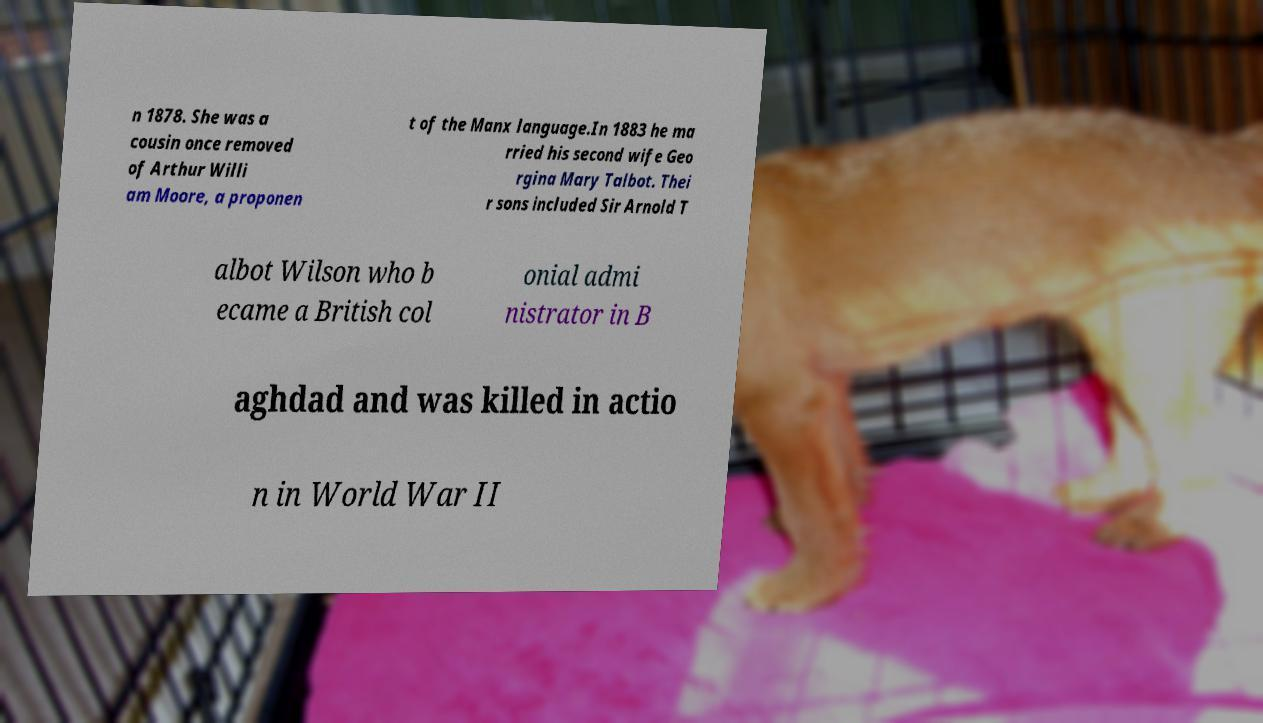Please read and relay the text visible in this image. What does it say? n 1878. She was a cousin once removed of Arthur Willi am Moore, a proponen t of the Manx language.In 1883 he ma rried his second wife Geo rgina Mary Talbot. Thei r sons included Sir Arnold T albot Wilson who b ecame a British col onial admi nistrator in B aghdad and was killed in actio n in World War II 